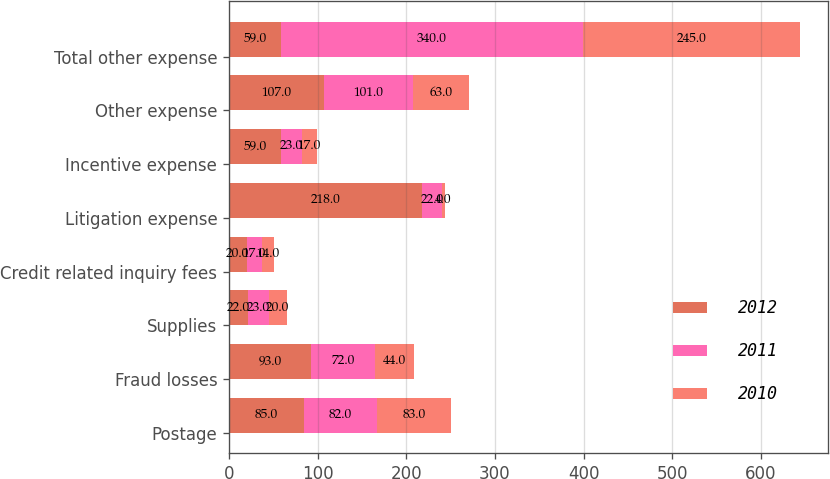Convert chart. <chart><loc_0><loc_0><loc_500><loc_500><stacked_bar_chart><ecel><fcel>Postage<fcel>Fraud losses<fcel>Supplies<fcel>Credit related inquiry fees<fcel>Litigation expense<fcel>Incentive expense<fcel>Other expense<fcel>Total other expense<nl><fcel>2012<fcel>85<fcel>93<fcel>22<fcel>20<fcel>218<fcel>59<fcel>107<fcel>59<nl><fcel>2011<fcel>82<fcel>72<fcel>23<fcel>17<fcel>22<fcel>23<fcel>101<fcel>340<nl><fcel>2010<fcel>83<fcel>44<fcel>20<fcel>14<fcel>4<fcel>17<fcel>63<fcel>245<nl></chart> 